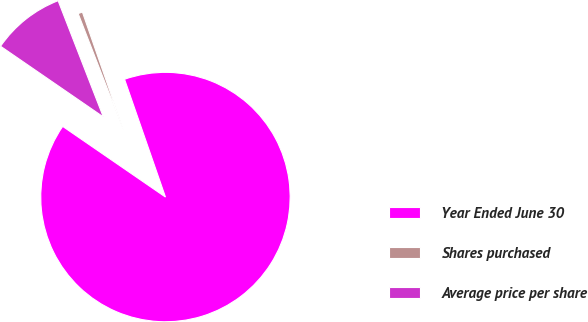Convert chart to OTSL. <chart><loc_0><loc_0><loc_500><loc_500><pie_chart><fcel>Year Ended June 30<fcel>Shares purchased<fcel>Average price per share<nl><fcel>89.91%<fcel>0.58%<fcel>9.51%<nl></chart> 